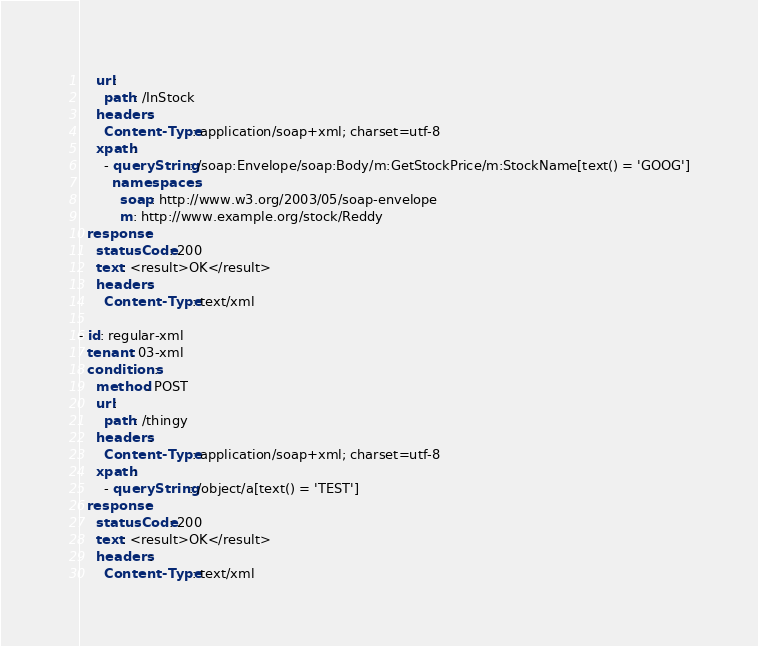<code> <loc_0><loc_0><loc_500><loc_500><_YAML_>    url:
      path: /InStock
    headers:
      Content-Type: application/soap+xml; charset=utf-8
    xpath:
      - queryString: /soap:Envelope/soap:Body/m:GetStockPrice/m:StockName[text() = 'GOOG']
        namespaces:
          soap: http://www.w3.org/2003/05/soap-envelope
          m: http://www.example.org/stock/Reddy
  response:
    statusCode: 200
    text: <result>OK</result>
    headers:
      Content-Type: text/xml

- id: regular-xml
  tenant: 03-xml
  conditions:
    method: POST
    url:
      path: /thingy
    headers:
      Content-Type: application/soap+xml; charset=utf-8
    xpath:
      - queryString: /object/a[text() = 'TEST']
  response:
    statusCode: 200
    text: <result>OK</result>
    headers:
      Content-Type: text/xml</code> 